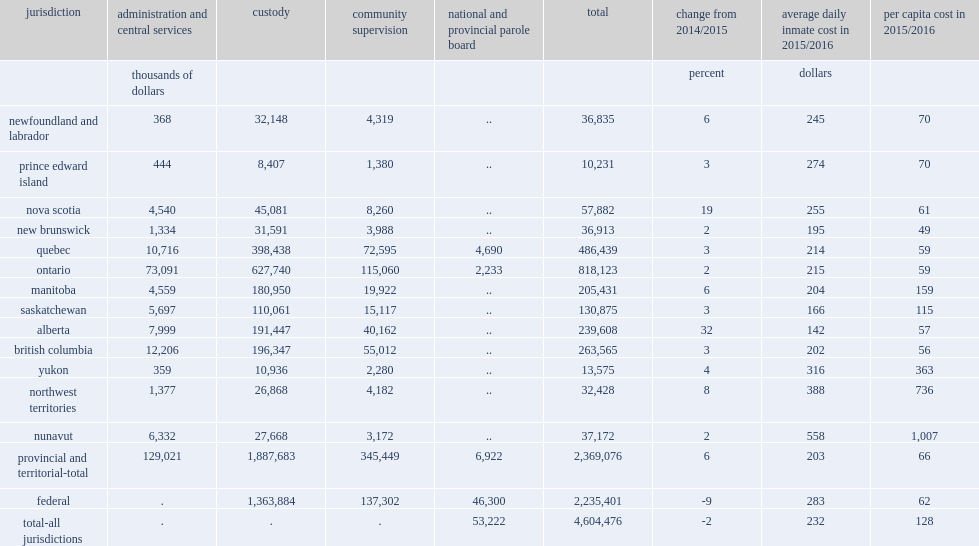Would you be able to parse every entry in this table? {'header': ['jurisdiction', 'administration and central services', 'custody', 'community supervision', 'national and provincial parole board', 'total', 'change from 2014/2015', 'average daily inmate cost in 2015/2016', 'per capita cost in 2015/2016'], 'rows': [['', 'thousands of dollars', '', '', '', '', 'percent', 'dollars', ''], ['newfoundland and labrador', '368', '32,148', '4,319', '..', '36,835', '6', '245', '70'], ['prince edward island', '444', '8,407', '1,380', '..', '10,231', '3', '274', '70'], ['nova scotia', '4,540', '45,081', '8,260', '..', '57,882', '19', '255', '61'], ['new brunswick', '1,334', '31,591', '3,988', '..', '36,913', '2', '195', '49'], ['quebec', '10,716', '398,438', '72,595', '4,690', '486,439', '3', '214', '59'], ['ontario', '73,091', '627,740', '115,060', '2,233', '818,123', '2', '215', '59'], ['manitoba', '4,559', '180,950', '19,922', '..', '205,431', '6', '204', '159'], ['saskatchewan', '5,697', '110,061', '15,117', '..', '130,875', '3', '166', '115'], ['alberta', '7,999', '191,447', '40,162', '..', '239,608', '32', '142', '57'], ['british columbia', '12,206', '196,347', '55,012', '..', '263,565', '3', '202', '56'], ['yukon', '359', '10,936', '2,280', '..', '13,575', '4', '316', '363'], ['northwest territories', '1,377', '26,868', '4,182', '..', '32,428', '8', '388', '736'], ['nunavut', '6,332', '27,668', '3,172', '..', '37,172', '2', '558', '1,007'], ['provincial and territorial-total', '129,021', '1,887,683', '345,449', '6,922', '2,369,076', '6', '203', '66'], ['federal', '.', '1,363,884', '137,302', '46,300', '2,235,401', '-9', '283', '62'], ['total-all jurisdictions', '.', '.', '.', '53,222', '4,604,476', '-2', '232', '128']]} In 2015/2016, how many dollars did adult correctional services operating expenditures in canada total? 4604476.0. In 2015/2016, what was the percent of adult correctional services operating expenditures in canada totalled a decrease from the previous year after adjusting for inflation? 2. What was the percent of the decrease in federal expenditures on corrections? 9. What was the percent of provincial and territorial spending increased? 6.0. How many dollars was total operating expenditures for correctional services equivalent for each person in the canadian population? 128.0. 